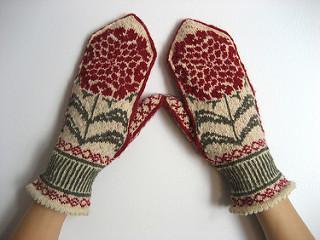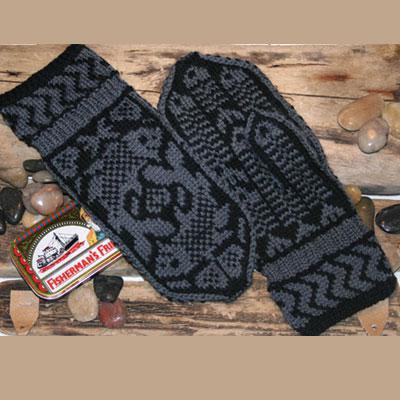The first image is the image on the left, the second image is the image on the right. Given the left and right images, does the statement "The items in the right image is laid on a plain white surface." hold true? Answer yes or no. No. The first image is the image on the left, the second image is the image on the right. For the images displayed, is the sentence "In 1 of the images, 2 gloves have thumbs pointing inward." factually correct? Answer yes or no. Yes. 